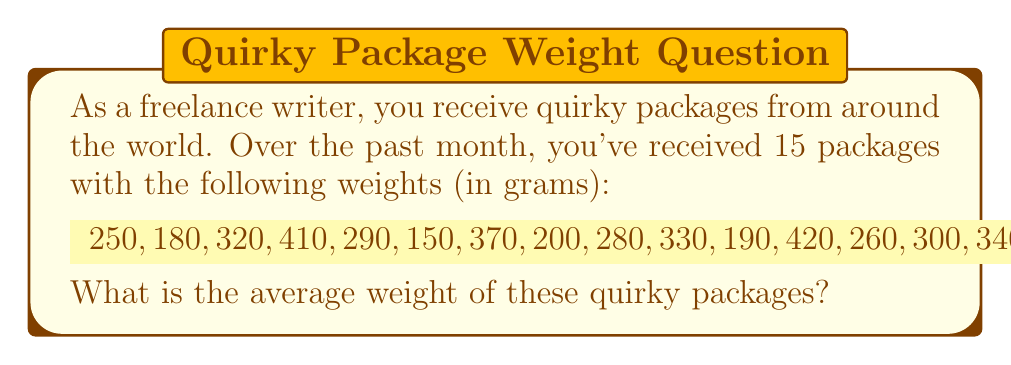Show me your answer to this math problem. To find the average weight of the quirky packages, we need to:

1. Sum up all the weights
2. Divide the sum by the total number of packages

Let's follow these steps:

1. Sum of all weights:
   $$\sum_{i=1}^{15} x_i = 250 + 180 + 320 + 410 + 290 + 150 + 370 + 200 + 280 + 330 + 190 + 420 + 260 + 300 + 340 = 4290$$

2. Number of packages: $n = 15$

3. Calculate the average (mean) weight:
   $$\bar{x} = \frac{\sum_{i=1}^{n} x_i}{n} = \frac{4290}{15} = 286$$

Therefore, the average weight of the quirky packages is 286 grams.
Answer: 286 grams 